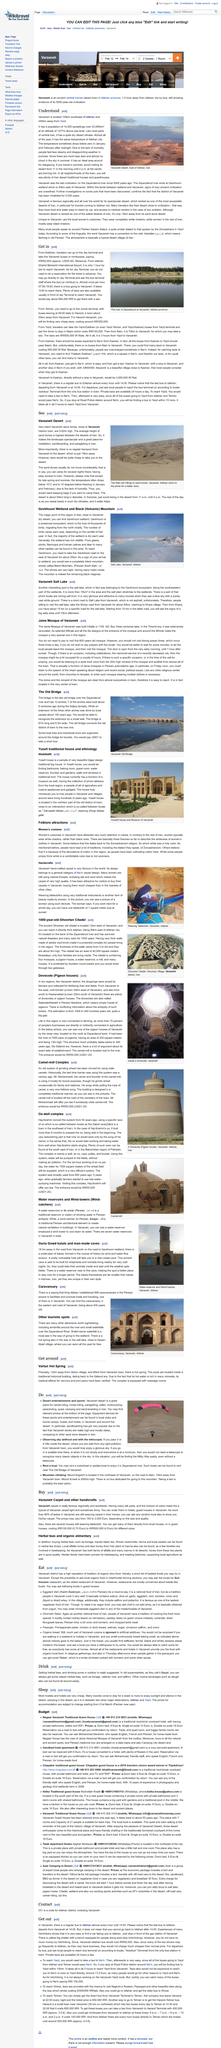Point out several critical features in this image. Hostels and hotels are commonly considered to be affordable accommodation options, with most establishments offering competitive prices that are significantly lower than those of traditional hotels. Varzaneh is an excellent location for surfing, as it has been confirmed by numerous positive reviews and testimonials. The distance from Varnazeh to the desert is 15 kilometers. The phrase "Get out" refers to the act of obtaining transportation from the city of Varzaneh. The river pictured is named Zayanderud. 